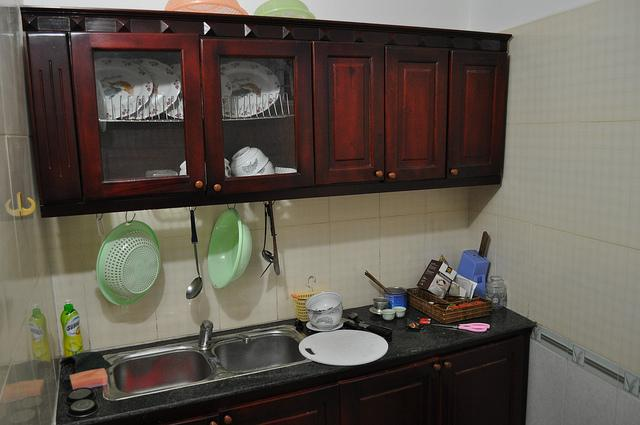What is the pink item on the counter? scissors 